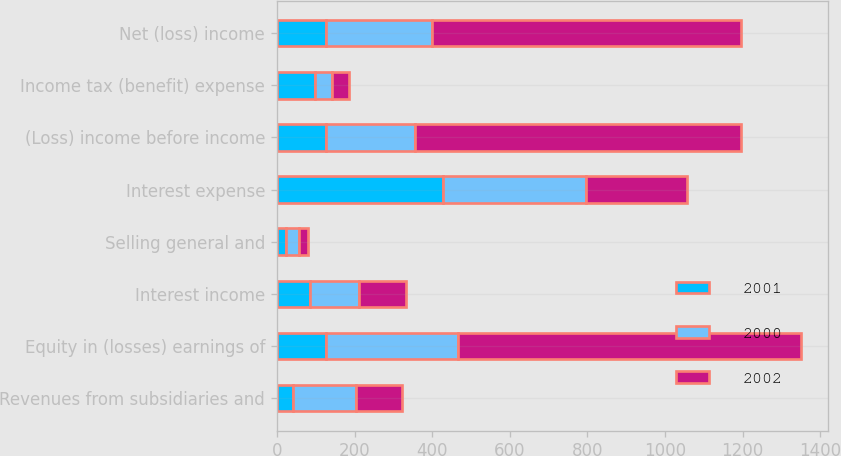Convert chart. <chart><loc_0><loc_0><loc_500><loc_500><stacked_bar_chart><ecel><fcel>Revenues from subsidiaries and<fcel>Equity in (losses) earnings of<fcel>Interest income<fcel>Selling general and<fcel>Interest expense<fcel>(Loss) income before income<fcel>Income tax (benefit) expense<fcel>Net (loss) income<nl><fcel>2001<fcel>41<fcel>127<fcel>84<fcel>24<fcel>428<fcel>127<fcel>98<fcel>127<nl><fcel>2000<fcel>164<fcel>340<fcel>127<fcel>34<fcel>367<fcel>230<fcel>43<fcel>273<nl><fcel>2002<fcel>116<fcel>884<fcel>122<fcel>21<fcel>262<fcel>839<fcel>44<fcel>795<nl></chart> 